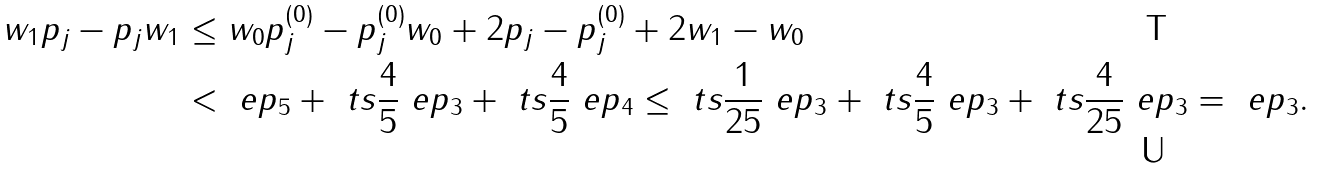<formula> <loc_0><loc_0><loc_500><loc_500>\| w _ { 1 } p _ { j } - p _ { j } w _ { 1 } \| & \leq \| w _ { 0 } p ^ { ( 0 ) } _ { j } - p ^ { ( 0 ) } _ { j } w _ { 0 } \| + 2 \| p _ { j } - p ^ { ( 0 ) } _ { j } \| + 2 \| w _ { 1 } - w _ { 0 } \| \\ & < \ e p _ { 5 } + { \ t s { \frac { 4 } { 5 } } } \ e p _ { 3 } + { \ t s { \frac { 4 } { 5 } } } \ e p _ { 4 } \leq { \ t s { \frac { 1 } { 2 5 } } } \ e p _ { 3 } + { \ t s { \frac { 4 } { 5 } } } \ e p _ { 3 } + { \ t s { \frac { 4 } { 2 5 } } } \ e p _ { 3 } = \ e p _ { 3 } .</formula> 